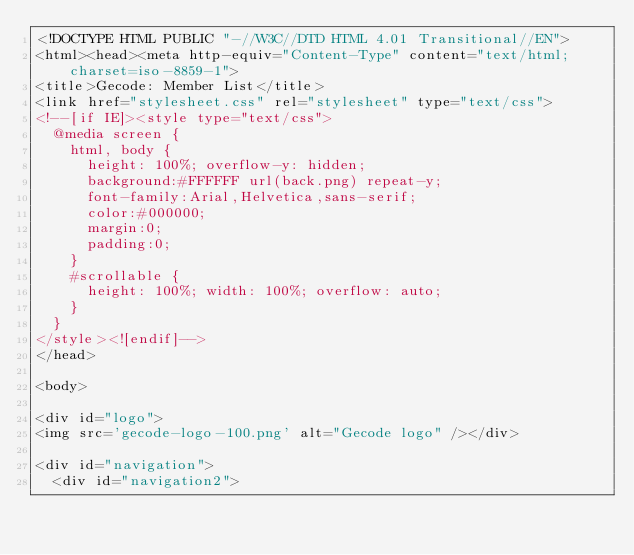Convert code to text. <code><loc_0><loc_0><loc_500><loc_500><_HTML_><!DOCTYPE HTML PUBLIC "-//W3C//DTD HTML 4.01 Transitional//EN">
<html><head><meta http-equiv="Content-Type" content="text/html;charset=iso-8859-1">
<title>Gecode: Member List</title>
<link href="stylesheet.css" rel="stylesheet" type="text/css">
<!--[if IE]><style type="text/css">
  @media screen {
    html, body {
      height: 100%; overflow-y: hidden;
      background:#FFFFFF url(back.png) repeat-y;
      font-family:Arial,Helvetica,sans-serif;
      color:#000000;
      margin:0;
      padding:0;
    }
    #scrollable {
      height: 100%; width: 100%; overflow: auto;
    }
  }
</style><![endif]-->
</head>

<body>

<div id="logo">
<img src='gecode-logo-100.png' alt="Gecode logo" /></div>

<div id="navigation">
  <div id="navigation2"></code> 